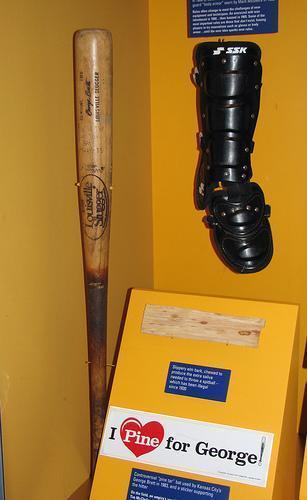How many baseball bats are there?
Give a very brief answer. 1. 